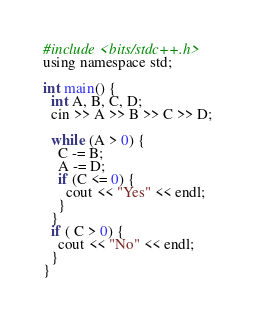<code> <loc_0><loc_0><loc_500><loc_500><_C_>#include <bits/stdc++.h>
using namespace std;

int main() {
  int A, B, C, D;
  cin >> A >> B >> C >> D;

  while (A > 0) {
    C -= B;
    A -= D;
    if (C <= 0) {
      cout << "Yes" << endl;
    }
  }
  if ( C > 0) {
    cout << "No" << endl;
  }
}</code> 